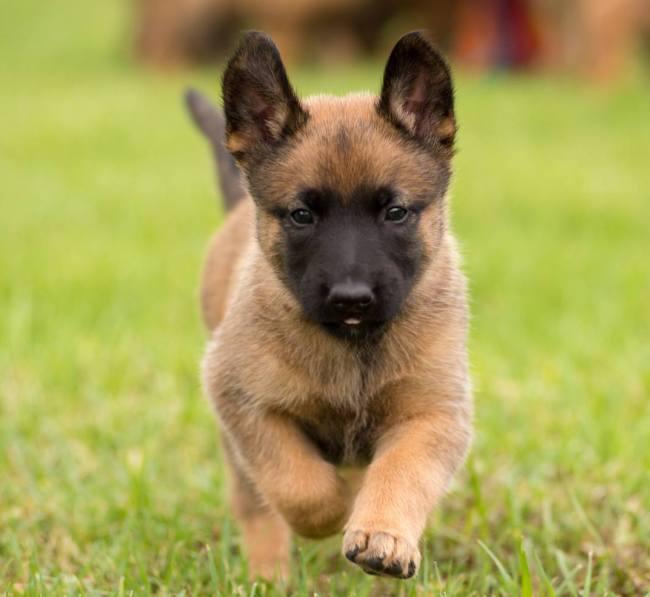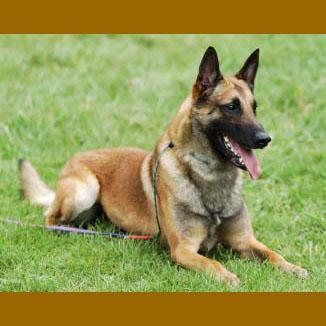The first image is the image on the left, the second image is the image on the right. For the images displayed, is the sentence "There is a total of 1 German Shepard whose face and body are completely front facing." factually correct? Answer yes or no. Yes. The first image is the image on the left, the second image is the image on the right. Evaluate the accuracy of this statement regarding the images: "a dog is laying in the grass with a leash on". Is it true? Answer yes or no. Yes. 